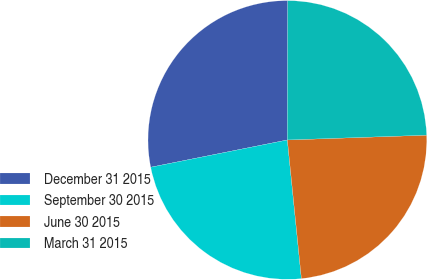<chart> <loc_0><loc_0><loc_500><loc_500><pie_chart><fcel>December 31 2015<fcel>September 30 2015<fcel>June 30 2015<fcel>March 31 2015<nl><fcel>28.17%<fcel>23.47%<fcel>23.94%<fcel>24.41%<nl></chart> 